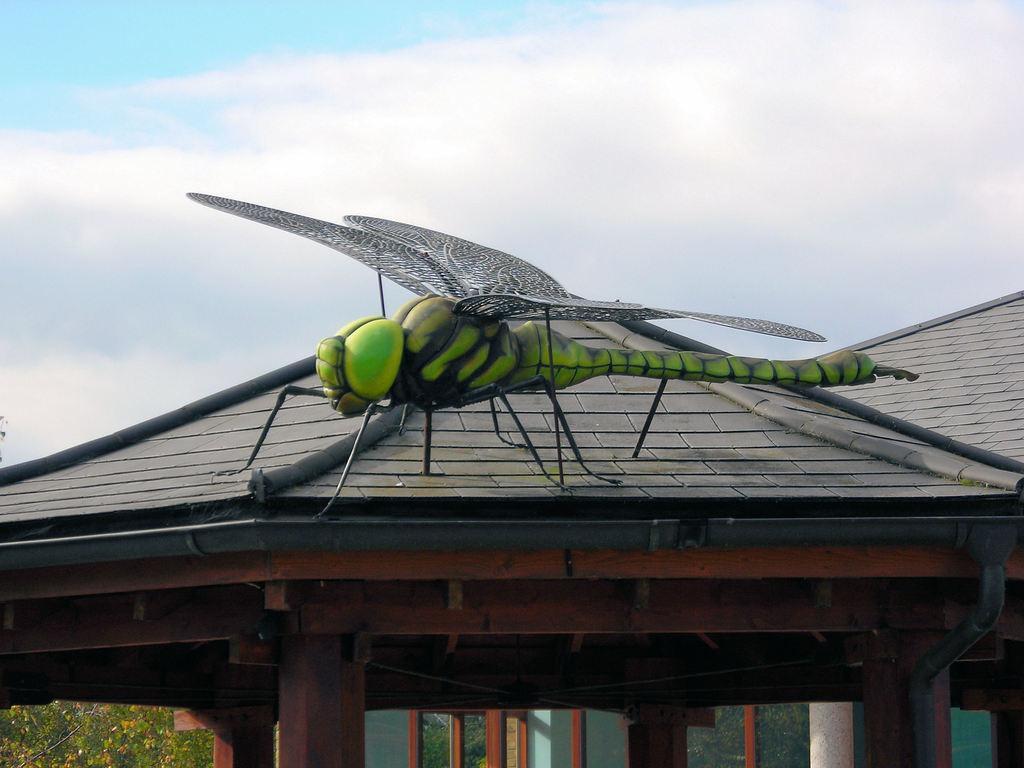In one or two sentences, can you explain what this image depicts? In this picture, we see a building with a grey color roof. On top of the roof, we see the statue of the insect in green color. In the background, we see the trees and a building in blue color. At the top, we see the sky. 